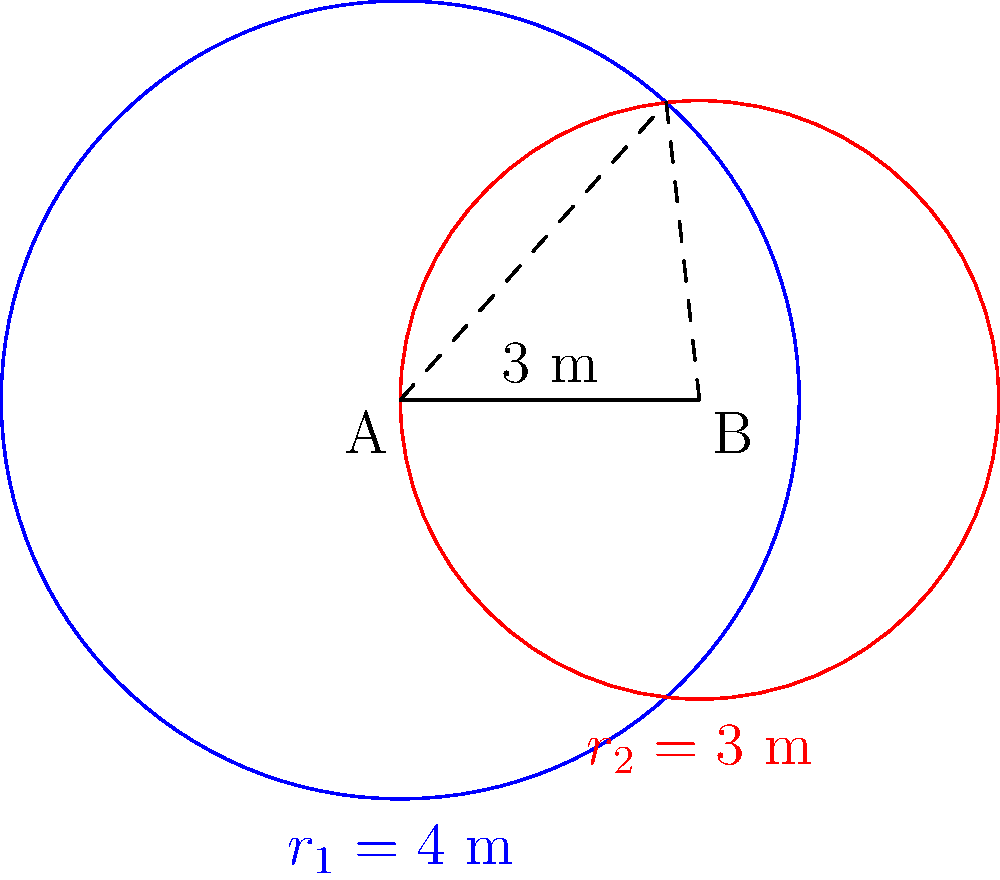Two circular vents, A and B, with radii 4 m and 3 m respectively, are installed in a manufacturing area. The centers of these vents are 3 m apart. Calculate the area of the overlapping region between these two vents to determine if additional ventilation is needed in this area. Round your answer to the nearest 0.01 m². To find the area of overlap between two circles, we need to use the formula for the area of circular segment. Let's approach this step-by-step:

1) First, we need to find the angle $\theta$ at the center of each circle that subtends the overlapping region.

2) We can do this using the cosine law in the triangle formed by the two circle centers and one of the intersection points:

   $\cos(\theta_1/2) = \frac{r_1^2 + d^2 - r_2^2}{2r_1d}$
   $\cos(\theta_2/2) = \frac{r_2^2 + d^2 - r_1^2}{2r_2d}$

   Where $d$ is the distance between the centers (3 m), $r_1 = 4$ m, and $r_2 = 3$ m.

3) Substituting these values:

   $\cos(\theta_1/2) = \frac{4^2 + 3^2 - 3^2}{2 * 4 * 3} = \frac{13}{24}$
   $\cos(\theta_2/2) = \frac{3^2 + 3^2 - 4^2}{2 * 3 * 3} = -\frac{1}{6}$

4) Taking arccos of both sides:

   $\theta_1 = 2 * \arccos(\frac{13}{24}) \approx 1.8235$ radians
   $\theta_2 = 2 * \arccos(-\frac{1}{6}) \approx 2.5194$ radians

5) The area of a circular segment is given by:
   $A = r^2(\theta - \sin(\theta))$

6) Therefore, the total overlapping area is:

   $A_{overlap} = r_1^2(\frac{\theta_1}{2} - \sin(\frac{\theta_1}{2})) + r_2^2(\frac{\theta_2}{2} - \sin(\frac{\theta_2}{2}))$

7) Substituting the values:

   $A_{overlap} = 4^2(\frac{1.8235}{2} - \sin(\frac{1.8235}{2})) + 3^2(\frac{2.5194}{2} - \sin(\frac{2.5194}{2}))$

8) Calculating this gives us approximately 5.69 m².
Answer: 5.69 m² 